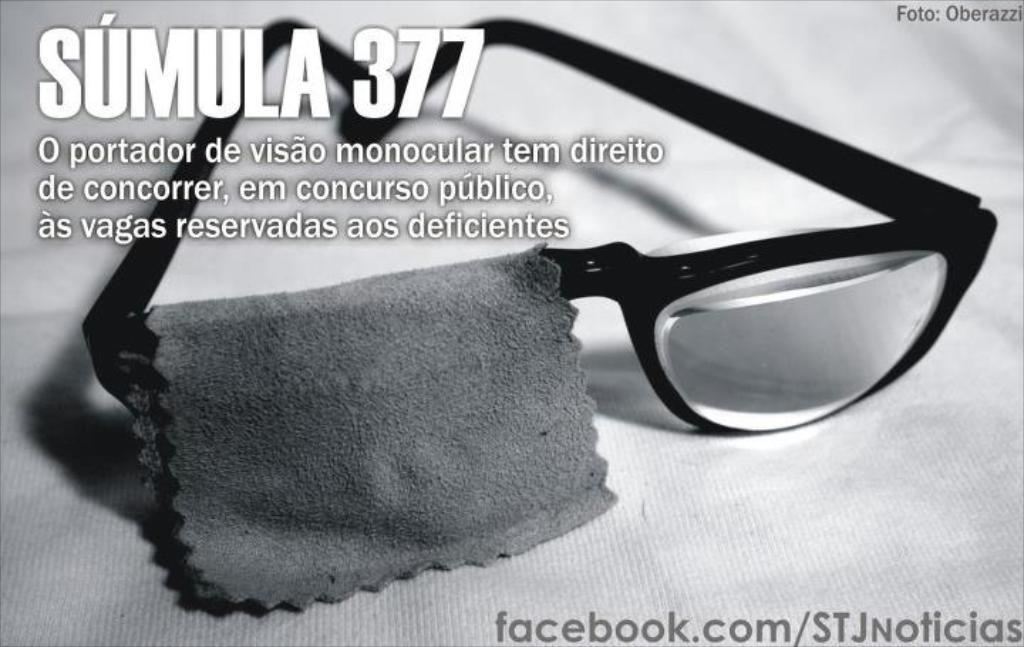What is the main object in the center of the image? There are spectacles and a cloth in the center of the image. What is written in the image? There is text written at the top and bottom of the image. What type of hobbies are mentioned in the image? There is no mention of hobbies in the image; it only contains spectacles, a cloth, and text. 